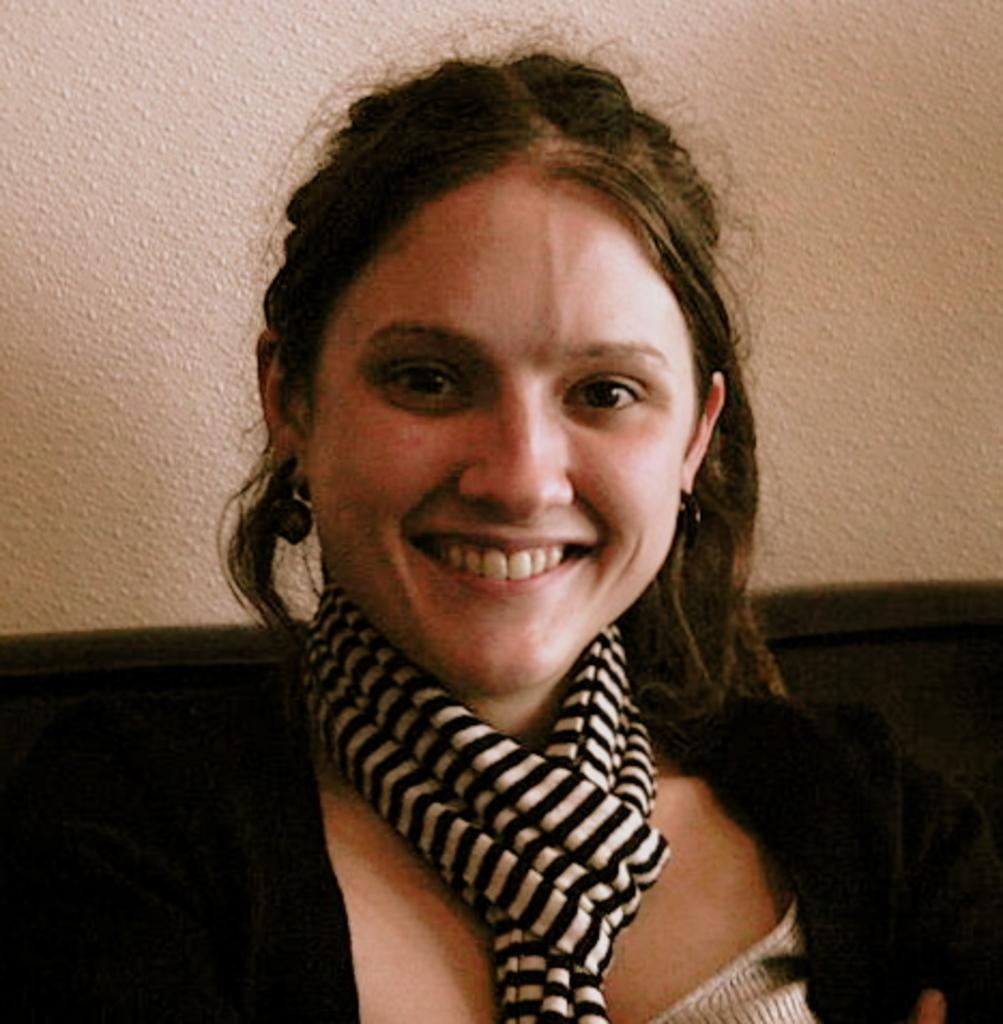Who is present in the image? There is a woman in the image. What is the woman doing in the image? The woman is smiling in the image. What can be seen behind the woman? There is a wall behind the woman. What type of scissors is the woman using to cut the fiction in the image? There are no scissors or fiction present in the image. 